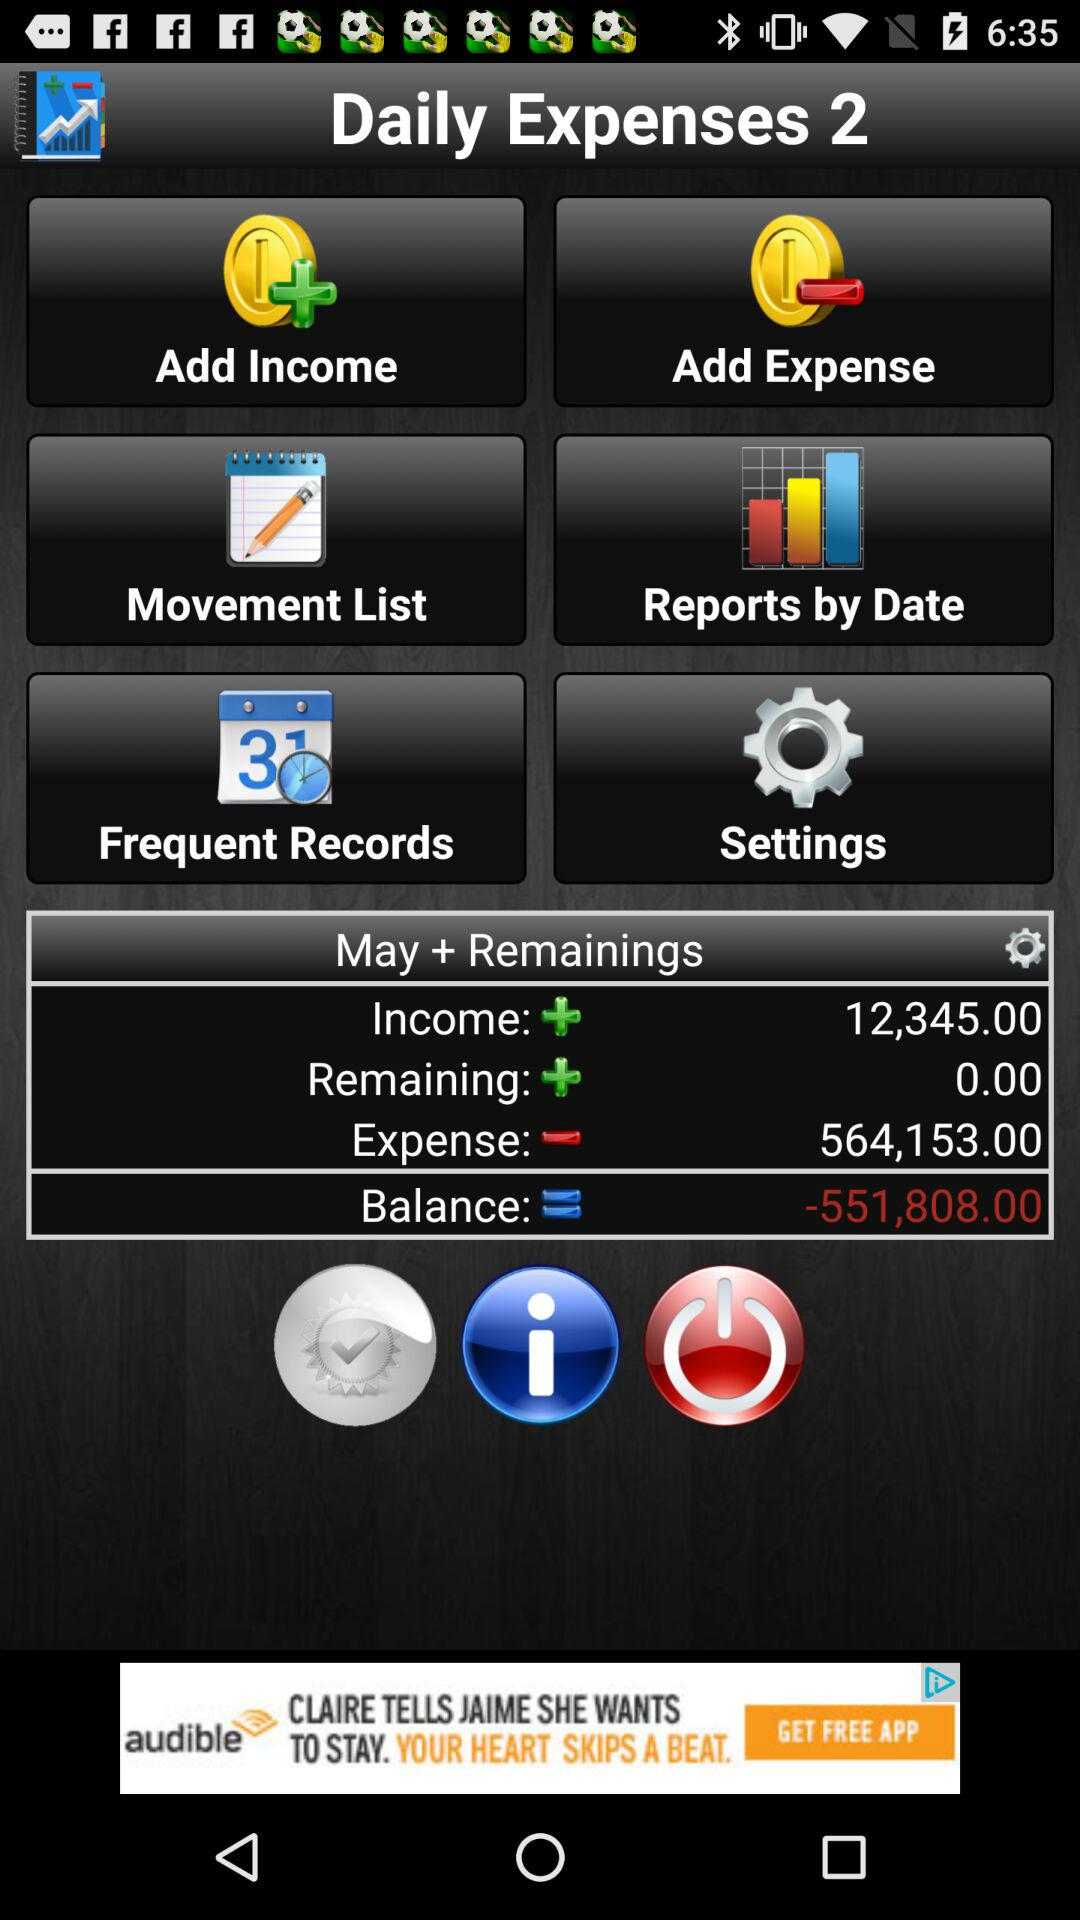What is the balance of my account?
Answer the question using a single word or phrase. -551,808.00 